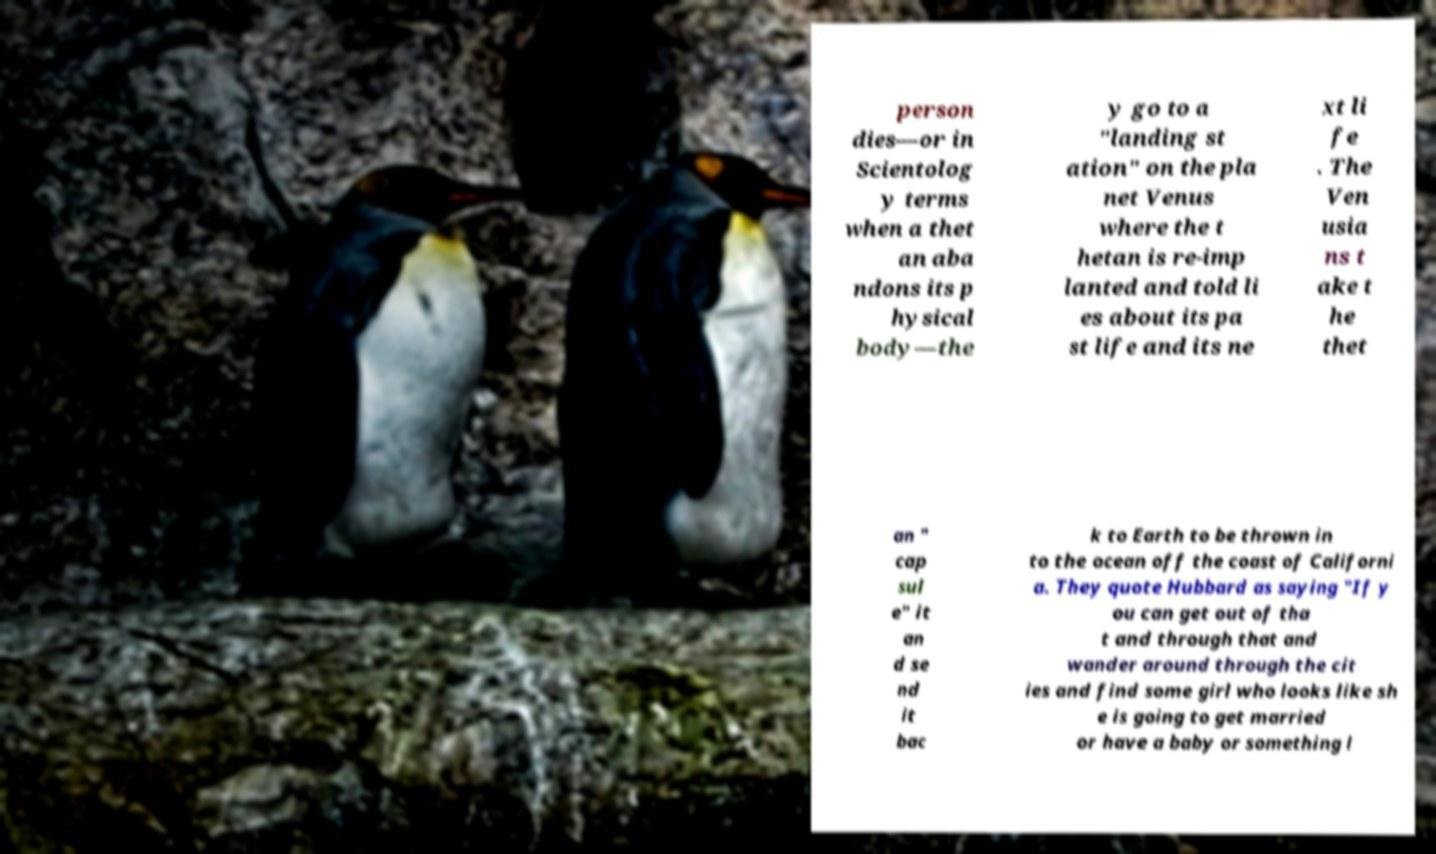I need the written content from this picture converted into text. Can you do that? person dies—or in Scientolog y terms when a thet an aba ndons its p hysical body—the y go to a "landing st ation" on the pla net Venus where the t hetan is re-imp lanted and told li es about its pa st life and its ne xt li fe . The Ven usia ns t ake t he thet an " cap sul e" it an d se nd it bac k to Earth to be thrown in to the ocean off the coast of Californi a. They quote Hubbard as saying "If y ou can get out of tha t and through that and wander around through the cit ies and find some girl who looks like sh e is going to get married or have a baby or something l 